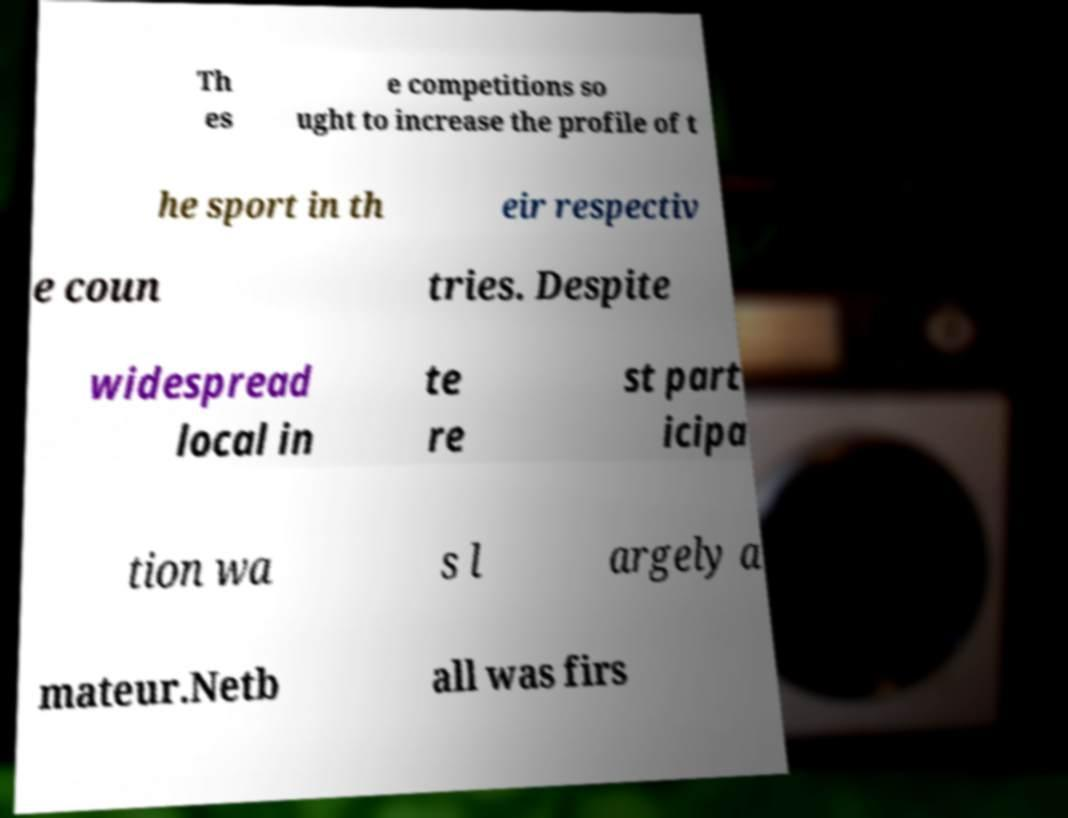Can you accurately transcribe the text from the provided image for me? Th es e competitions so ught to increase the profile of t he sport in th eir respectiv e coun tries. Despite widespread local in te re st part icipa tion wa s l argely a mateur.Netb all was firs 